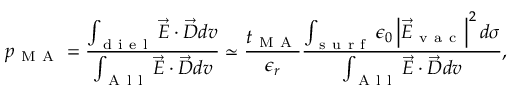Convert formula to latex. <formula><loc_0><loc_0><loc_500><loc_500>p _ { M A } = \frac { \int _ { d i e l } \vec { E } \cdot \vec { D } d v } { \int _ { A l l } \vec { E } \cdot \vec { D } d v } \simeq \frac { t _ { M A } } { \epsilon _ { r } } \frac { \int _ { s u r f } \epsilon _ { 0 } \left | \vec { E } _ { v a c } \right | ^ { 2 } d \sigma } { \int _ { A l l } \vec { E } \cdot \vec { D } d v } ,</formula> 